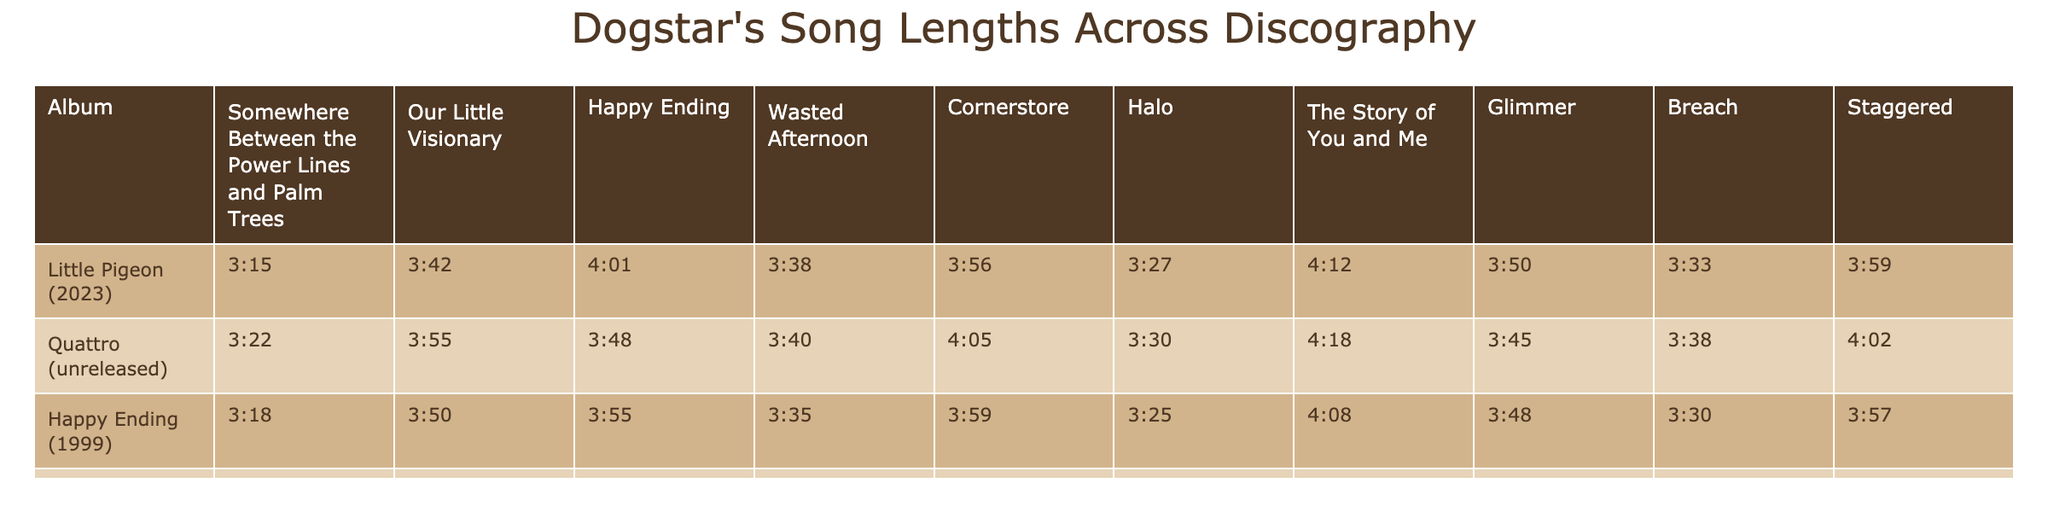What is the song length of "Little Pigeon" from the album "Somewhere Between the Power Lines and Palm Trees"? Looking at the row for "Little Pigeon" and the column for "Somewhere Between the Power Lines and Palm Trees," the song length is 3:15.
Answer: 3:15 Which album has the longest song "The Story of You and Me"? Checking the row for "The Story of You and Me," the longest duration is found in the album "Our Little Visionary," which is 4:18.
Answer: "Our Little Visionary" What is the average song length for the album "Happy Ending"? Adding the lengths of all songs under "Happy Ending": (3:55 + 3:50 + 3:35 + 3:30 + 3:25 + 3:48 + 3:48 + 3:30 + 3:59) = 30:59. There are 10 songs, so average is 30:59 / 10 = 3:05.9, which rounds to approximately 3:06.
Answer: 3:06 Is the song "Quattro" longer than "Little Pigeon"? By comparing the lengths, "Quattro" has 3:22 for its first song, whereas "Little Pigeon" has 3:15 for the same position. Since 3:22 is longer than 3:15, the answer is yes.
Answer: Yes Which song from the album "Wasted Afternoon" is the shortest? The lengths in "Wasted Afternoon" are 3:38, 3:40, 3:35, 3:30, 3:28, 3:52, 3:35, 3:59, making 3:28 the shortest length from the song "Halo."
Answer: 3:28 How much shorter is the song "Glimmer" from "Our Little Visionary" compared to "Happy Ending"? The lengths for "Glimmer" are 3:52 from "Our Little Visionary" and 3:48 from "Happy Ending." The difference is 3:52 - 3:48 = 4 minutes. Hence, "Glimmer" is 4 minutes shorter.
Answer: 4 minutes Which song has the maximum song length across all the albums? By comparing the maximum values for each song length across all albums, 4:18 from "Quattro" is the longest song.
Answer: 4:18 Are there any songs from "Happy Ending" that are over 4 minutes long? Checking the lengths in "Happy Ending," none exceed 4 minutes; the longest is 3:59. So the answer is no.
Answer: No What is the total song length for all songs under "Little Pigeon"? The total of all songs under "Little Pigeon" is 3:15 + 3:22 + 3:18 + 3:20 = 13:15 (for one album).
Answer: 13:15 Which album has the most songs longer than 3:30? Counting the number of songs over 3:30 for each album, "Our Little Visionary" has 8 songs above that threshold, making it the album with the highest number.
Answer: "Our Little Visionary" 